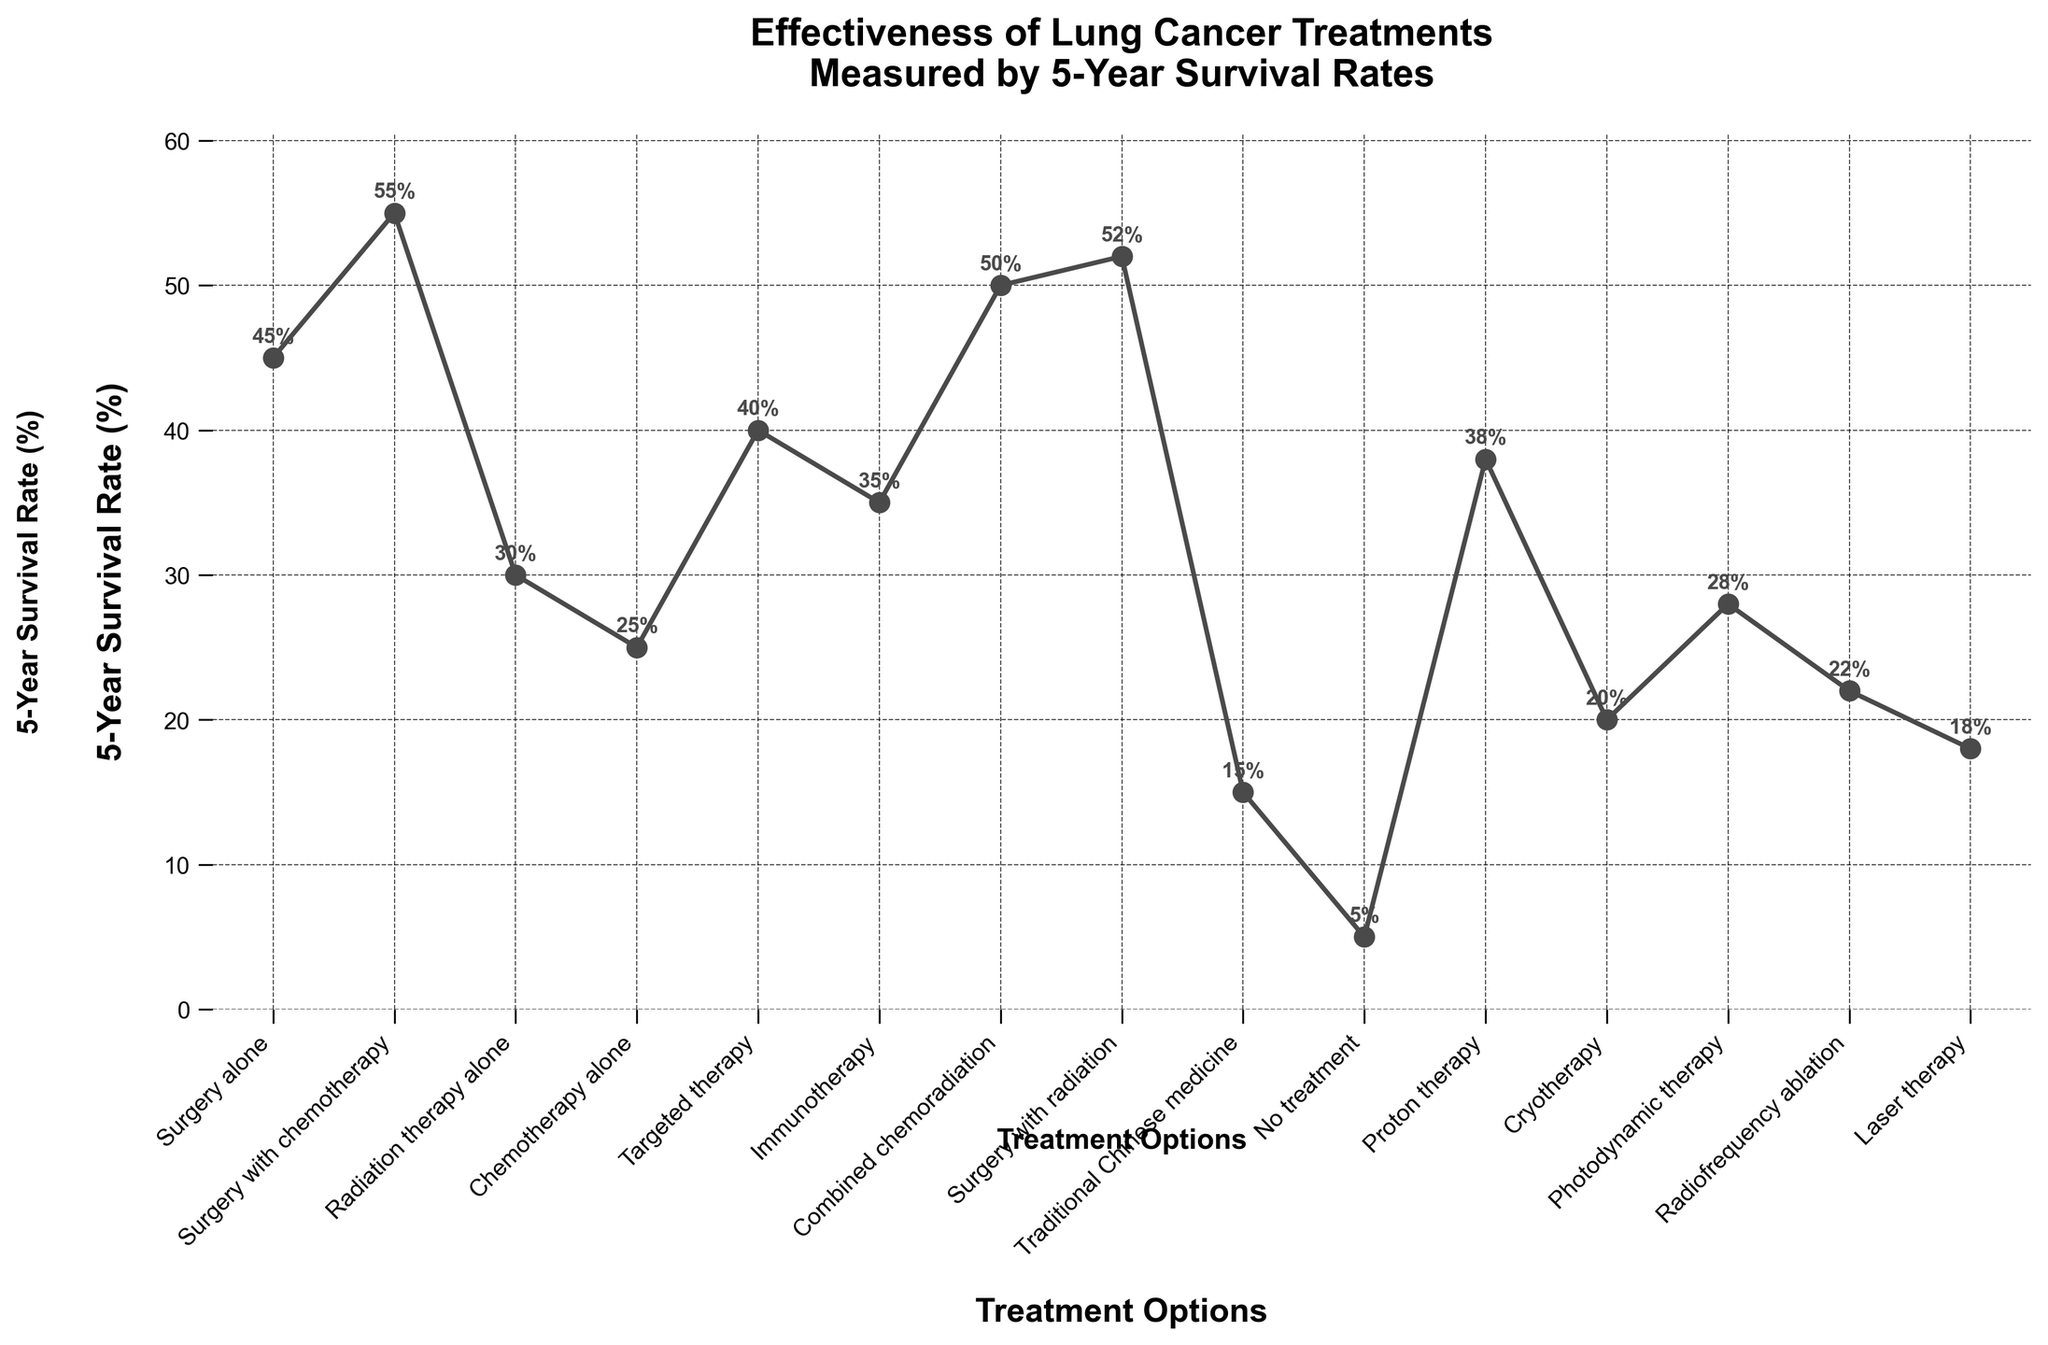What treatment has the highest 5-year survival rate? The figure shows different treatments with their corresponding survival rates. Look for the treatment with the highest value on the y-axis.
Answer: Surgery with chemotherapy Which treatments have a survival rate above 50%? Identify treatments that have survival rates marked above the 50% line on the y-axis.
Answer: Surgery with chemotherapy, Combined chemoradiation, Surgery with radiation How much higher is the survival rate of surgery with chemotherapy compared to no treatment? Locate the survival rates for both treatments, then subtract the survival rate of no treatment from that of surgery with chemotherapy (55% - 5%).
Answer: 50% Which treatment has the lowest 5-year survival rate? Look for the treatment with the lowest value on the y-axis.
Answer: No treatment Between targeted therapy and immunotherapy, which has the higher survival rate? Compare the survival rates marked for targeted therapy and immunotherapy on the y-axis.
Answer: Targeted therapy What is the difference in survival rates between radiation therapy alone and combined chemoradiation? Find the survival rates for both treatments and subtract the smaller rate from the larger one (50% - 30%).
Answer: 20% Which treatment has a survival rate closest to 30%? Look for the treatment whose survival rate is either slightly above or below 30% and closest to it.
Answer: Radiation therapy alone Between surgery with radiation and cryotherapy, how much greater is the survival rate for the former? Identify the survival rates for both treatments and subtract the smaller rate from the larger one (52% - 20%).
Answer: 32% What is the average 5-year survival rate for all the treatments? Sum the survival rates of all treatments and divide by the number of treatments [(45 + 55 + 30 + 25 + 40 + 35 + 50 + 52 + 15 + 5 + 38 + 20 + 28 + 22 + 18) / 15].
Answer: 33.2% Which treatments have a survival rate of 40% or more but less than 50%? Identify treatments that fall within this range by looking at the survival rates.
Answer: Targeted therapy, Immunotherapy, Proton therapy 